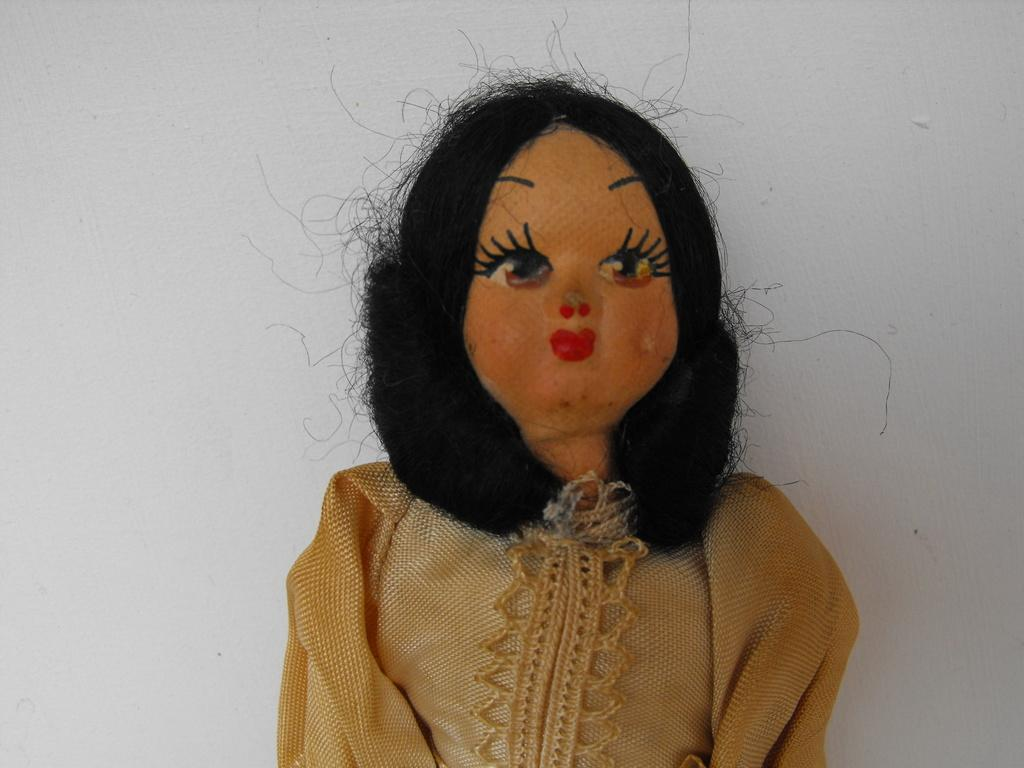What is the main subject of the image? There is a doll in the image. What color is the background of the image? The background of the image is white. What type of face can be seen on the cushion in the image? There is no cushion present in the image, and therefore no face can be seen on it. 